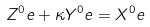Convert formula to latex. <formula><loc_0><loc_0><loc_500><loc_500>Z ^ { 0 } e + \kappa Y ^ { 0 } e & = X ^ { 0 } e</formula> 